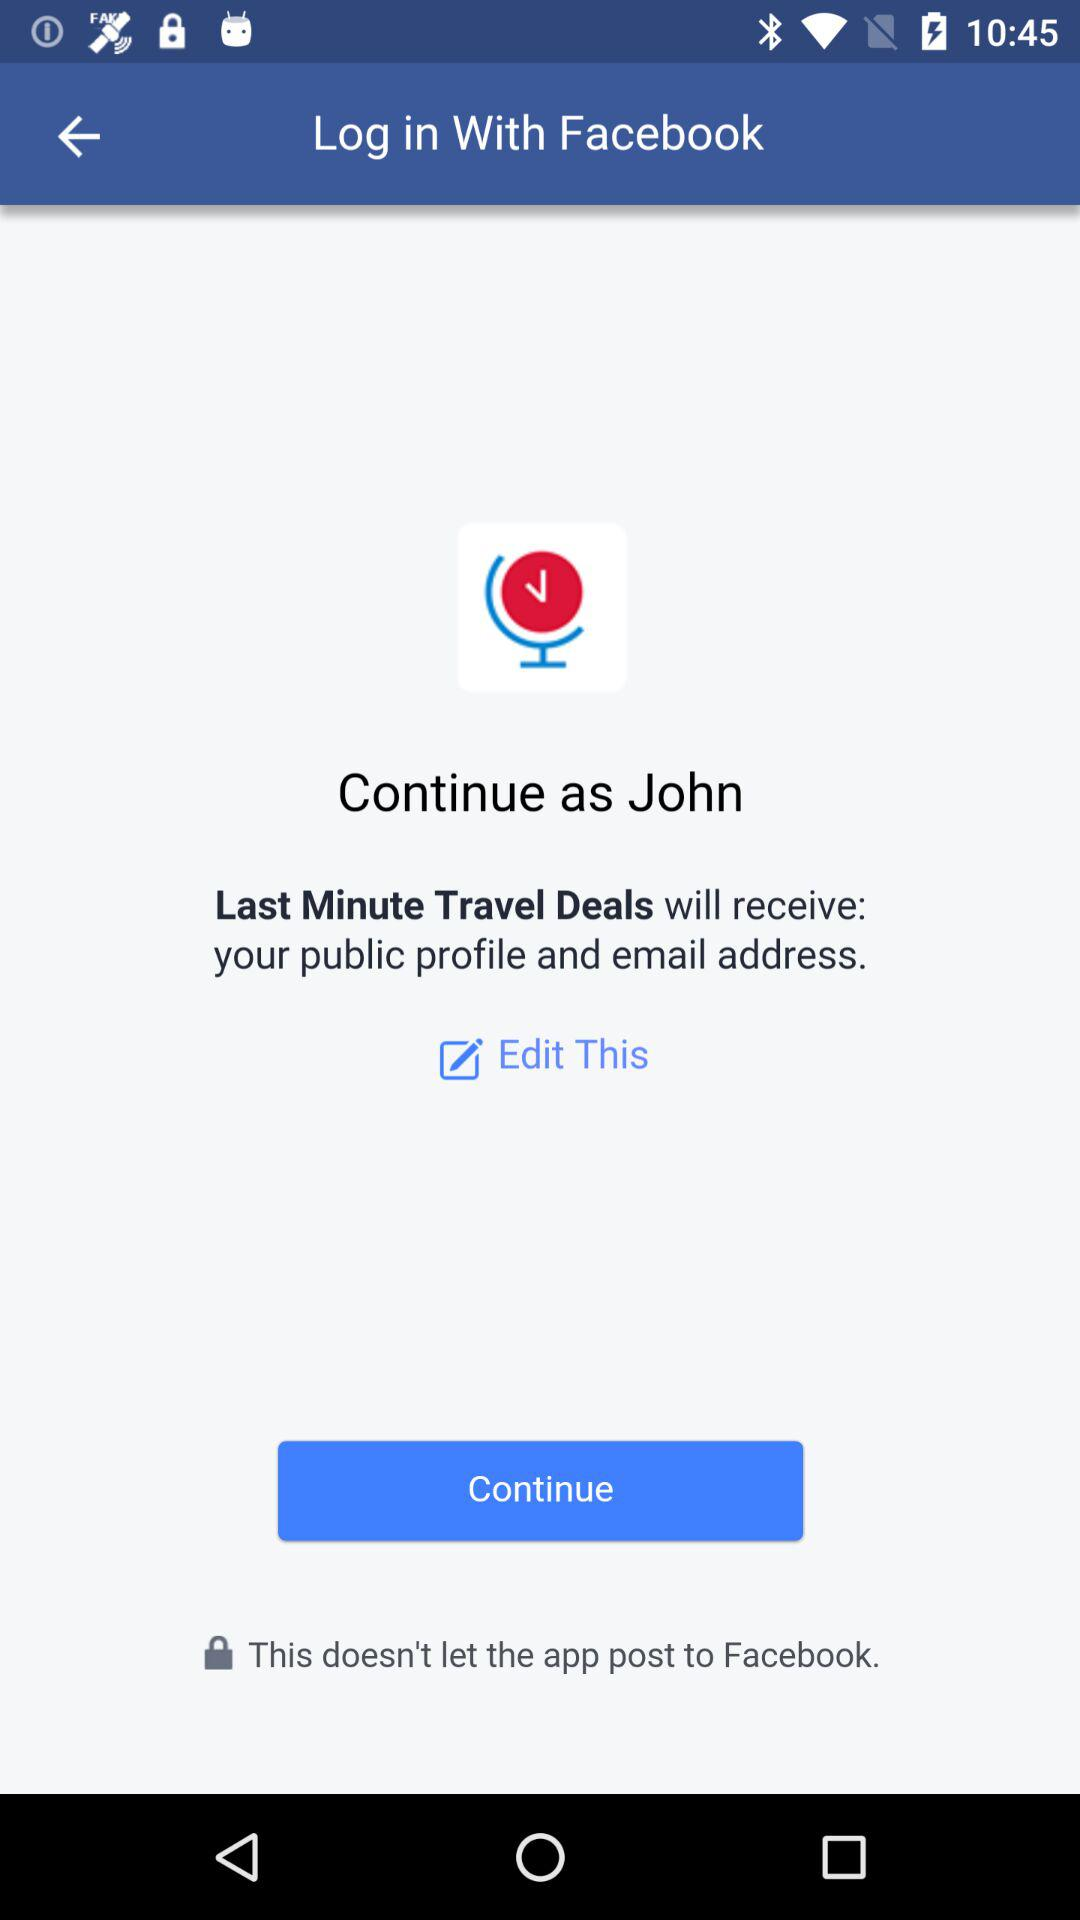How can we log in? You can log in with "Facebook". 